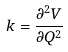<formula> <loc_0><loc_0><loc_500><loc_500>k = \frac { \partial ^ { 2 } V } { \partial Q ^ { 2 } }</formula> 